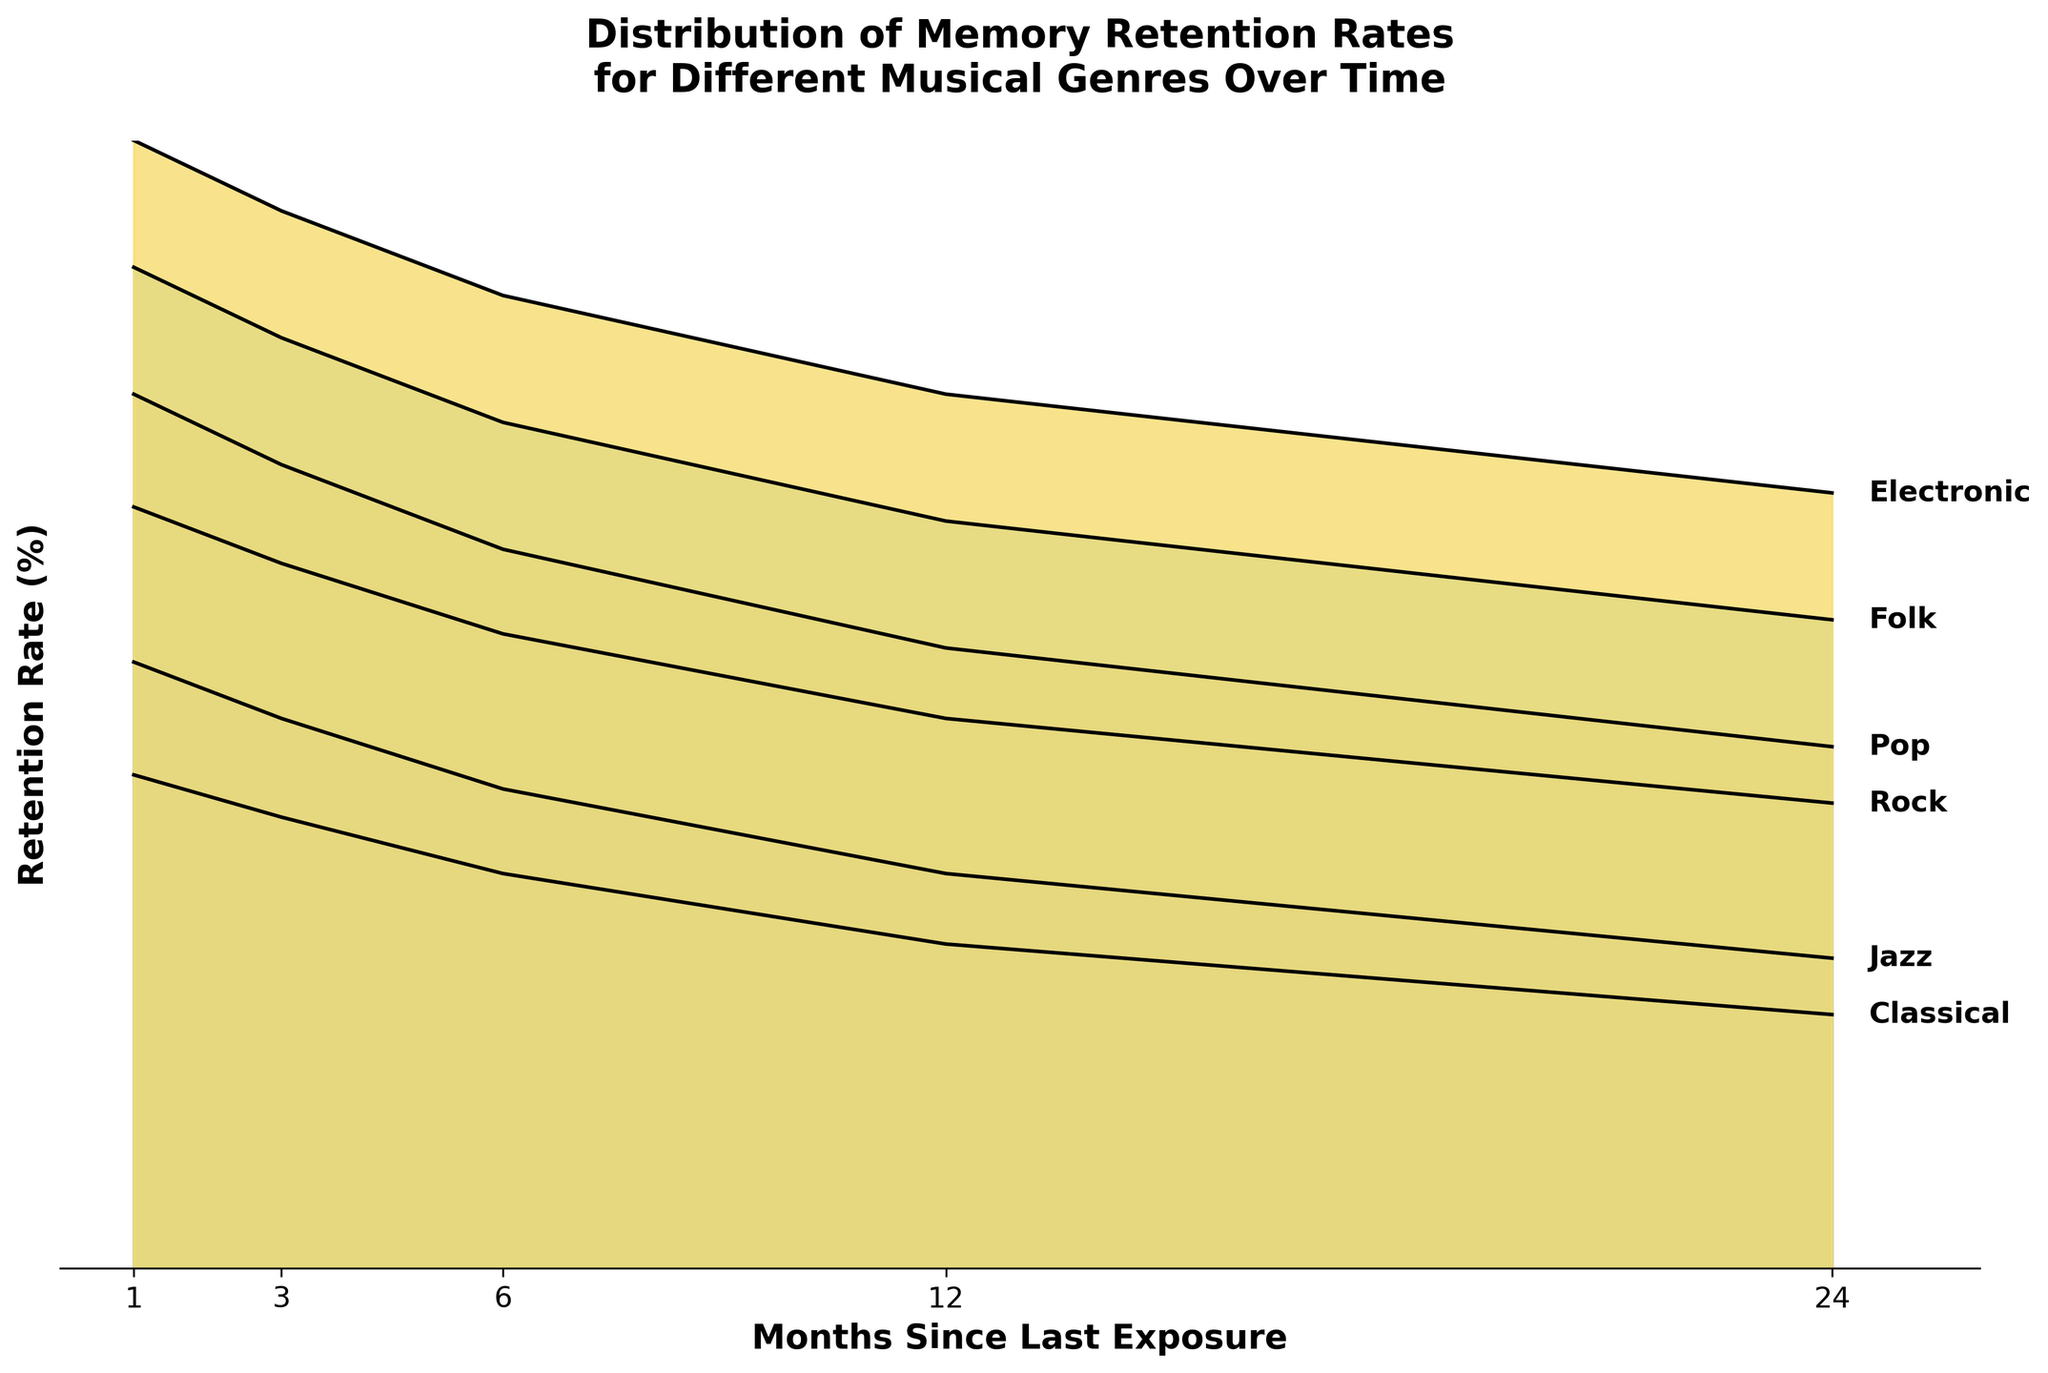What's the title of the figure? The title of the figure is displayed at the top and reads "Distribution of Memory Retention Rates for Different Musical Genres Over Time".
Answer: Distribution of Memory Retention Rates for Different Musical Genres Over Time How many genres are represented in the figure? The figure has labels for each genre at the end of the retention rate lines. Counting these labels, there are six genres represented in the figure.
Answer: Six What is the retention rate for Rock music 6 months after the last exposure? To find the retention rate for Rock music 6 months after the last exposure, locate the line labeled "Rock" and see where it intersects with "6" on the x-axis. The y-axis value at this point is 85.
Answer: 85 Which genre has the highest initial retention rate? Compare the retention rates for each genre at "1 month" since exposure. The lines start at different y-values, and the highest y-value corresponds to Classical music with a rate of 95%.
Answer: Classical How does the retention rate for Pop music change between 12 and 24 months since the last exposure? Look at the y-values for the line labeled "Pop" at "12 months" and "24 months". The retention rate decreases from 74% to 67%. Calculate the difference: 74 - 67 = 7.
Answer: Decreases by 7% Which genre experiences the steepest decline in retention rate over time? To determine the steepest decline, compare the decline in percentage points for each genre from the start (1 month) to the end (24 months). Electronic music drops from 90% to 65%, a decline of 25 points, which is the steepest.
Answer: Electronic What is the average retention rate for Jazz music over the entire period? To find the average, sum the retention rates for Jazz music at all time points and divide by the number of points: (93 + 89 + 84 + 78 + 72) / 5 = 83.2.
Answer: 83.2 Which genre retains the highest percentage after 24 months since the last exposure? Look at the retention rate values at "24 months" for all genres. The highest retention rate at 24 months is for Classical music, which is 78%.
Answer: Classical What is the difference in retention rate between Jazz and Folk music at 12 months? Check the retention rate values for Jazz and Folk music at "12 months". Jazz is 78% and Folk is 73%, so the difference is 78 - 73 = 5.
Answer: 5 How does the memory retention rate for Classical music compare to Rock music at 3 months since the last exposure? Compare the y-values for both Classical and Rock at "3 months". Classical is at 92% and Rock at 90%. Classical has a slightly higher retention rate than Rock.
Answer: Classical is higher 